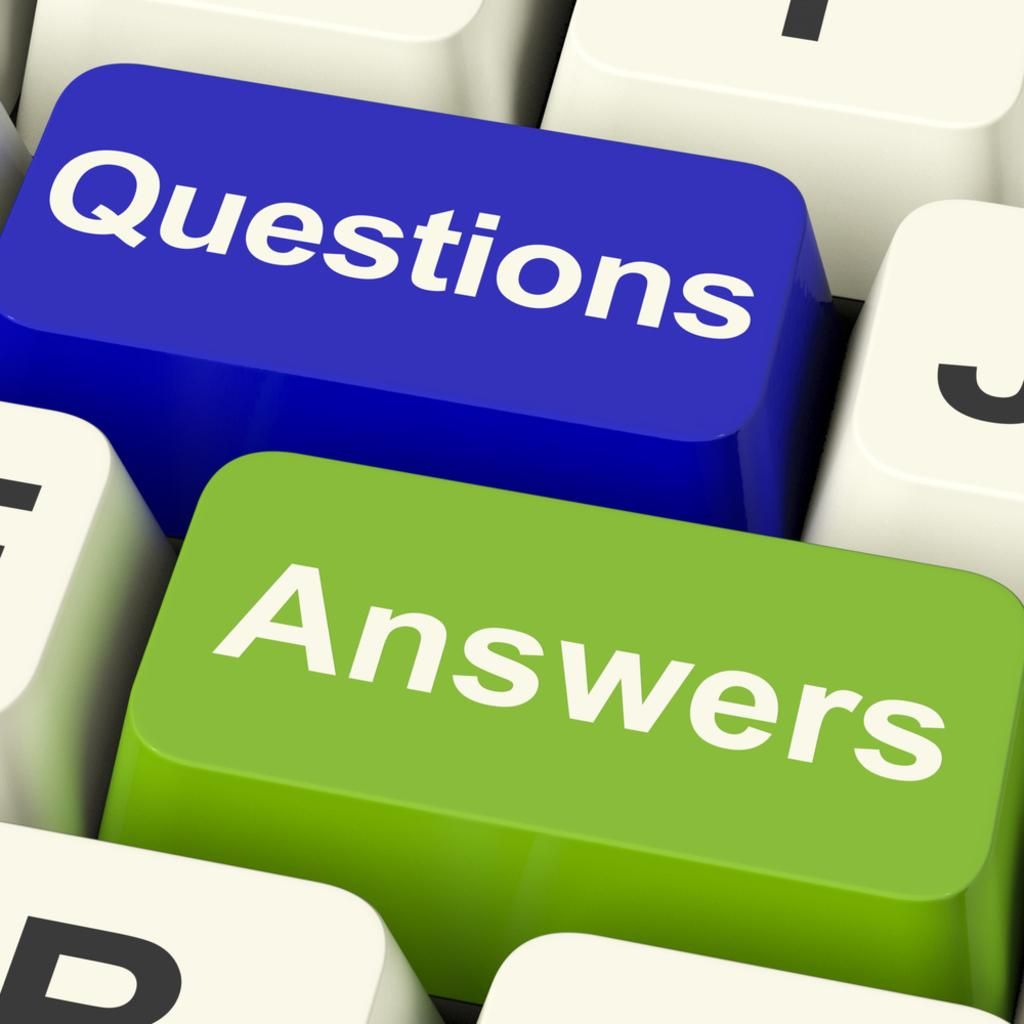Provide a one-sentence caption for the provided image. a computer keyboard with a blue key for Questions and green one for Answers. 